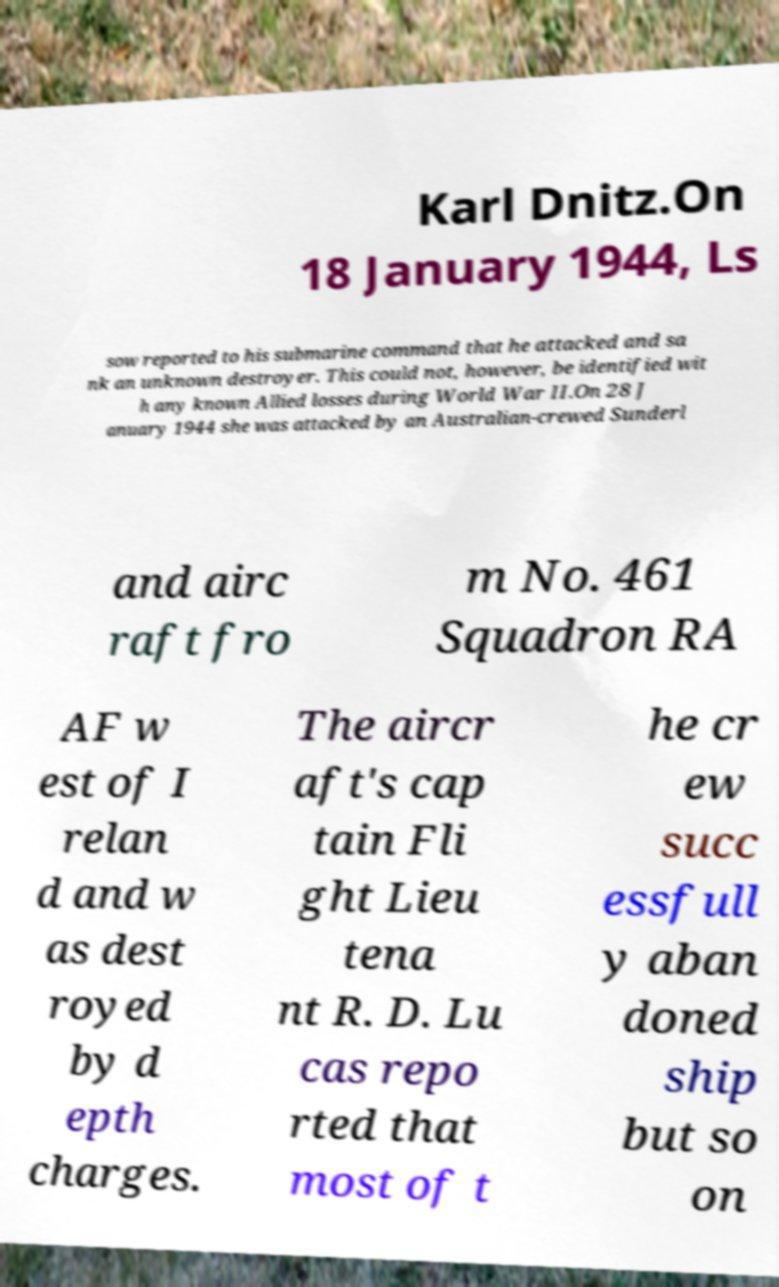Can you accurately transcribe the text from the provided image for me? Karl Dnitz.On 18 January 1944, Ls sow reported to his submarine command that he attacked and sa nk an unknown destroyer. This could not, however, be identified wit h any known Allied losses during World War II.On 28 J anuary 1944 she was attacked by an Australian-crewed Sunderl and airc raft fro m No. 461 Squadron RA AF w est of I relan d and w as dest royed by d epth charges. The aircr aft's cap tain Fli ght Lieu tena nt R. D. Lu cas repo rted that most of t he cr ew succ essfull y aban doned ship but so on 